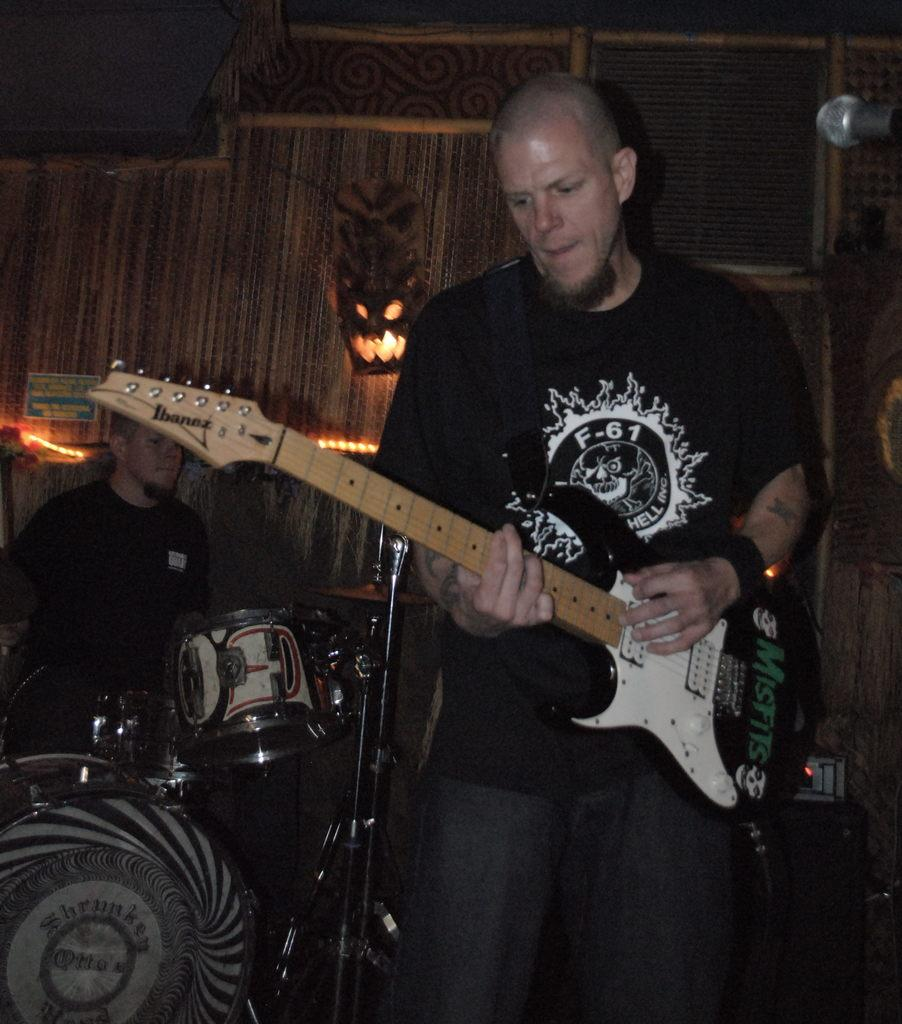What is the person in the foreground of the image doing? The person is standing and playing the guitar. What instrument is the person sitting in the background playing? The person sitting in the background is playing electronic drums. What can be seen in the background of the image? There is a wall in the background. What type of quilt is being used as a prop by the actor in the image? There is no actor or quilt present in the image. The image features two people playing musical instruments, a guitar and electronic drums, with a wall in the background. 